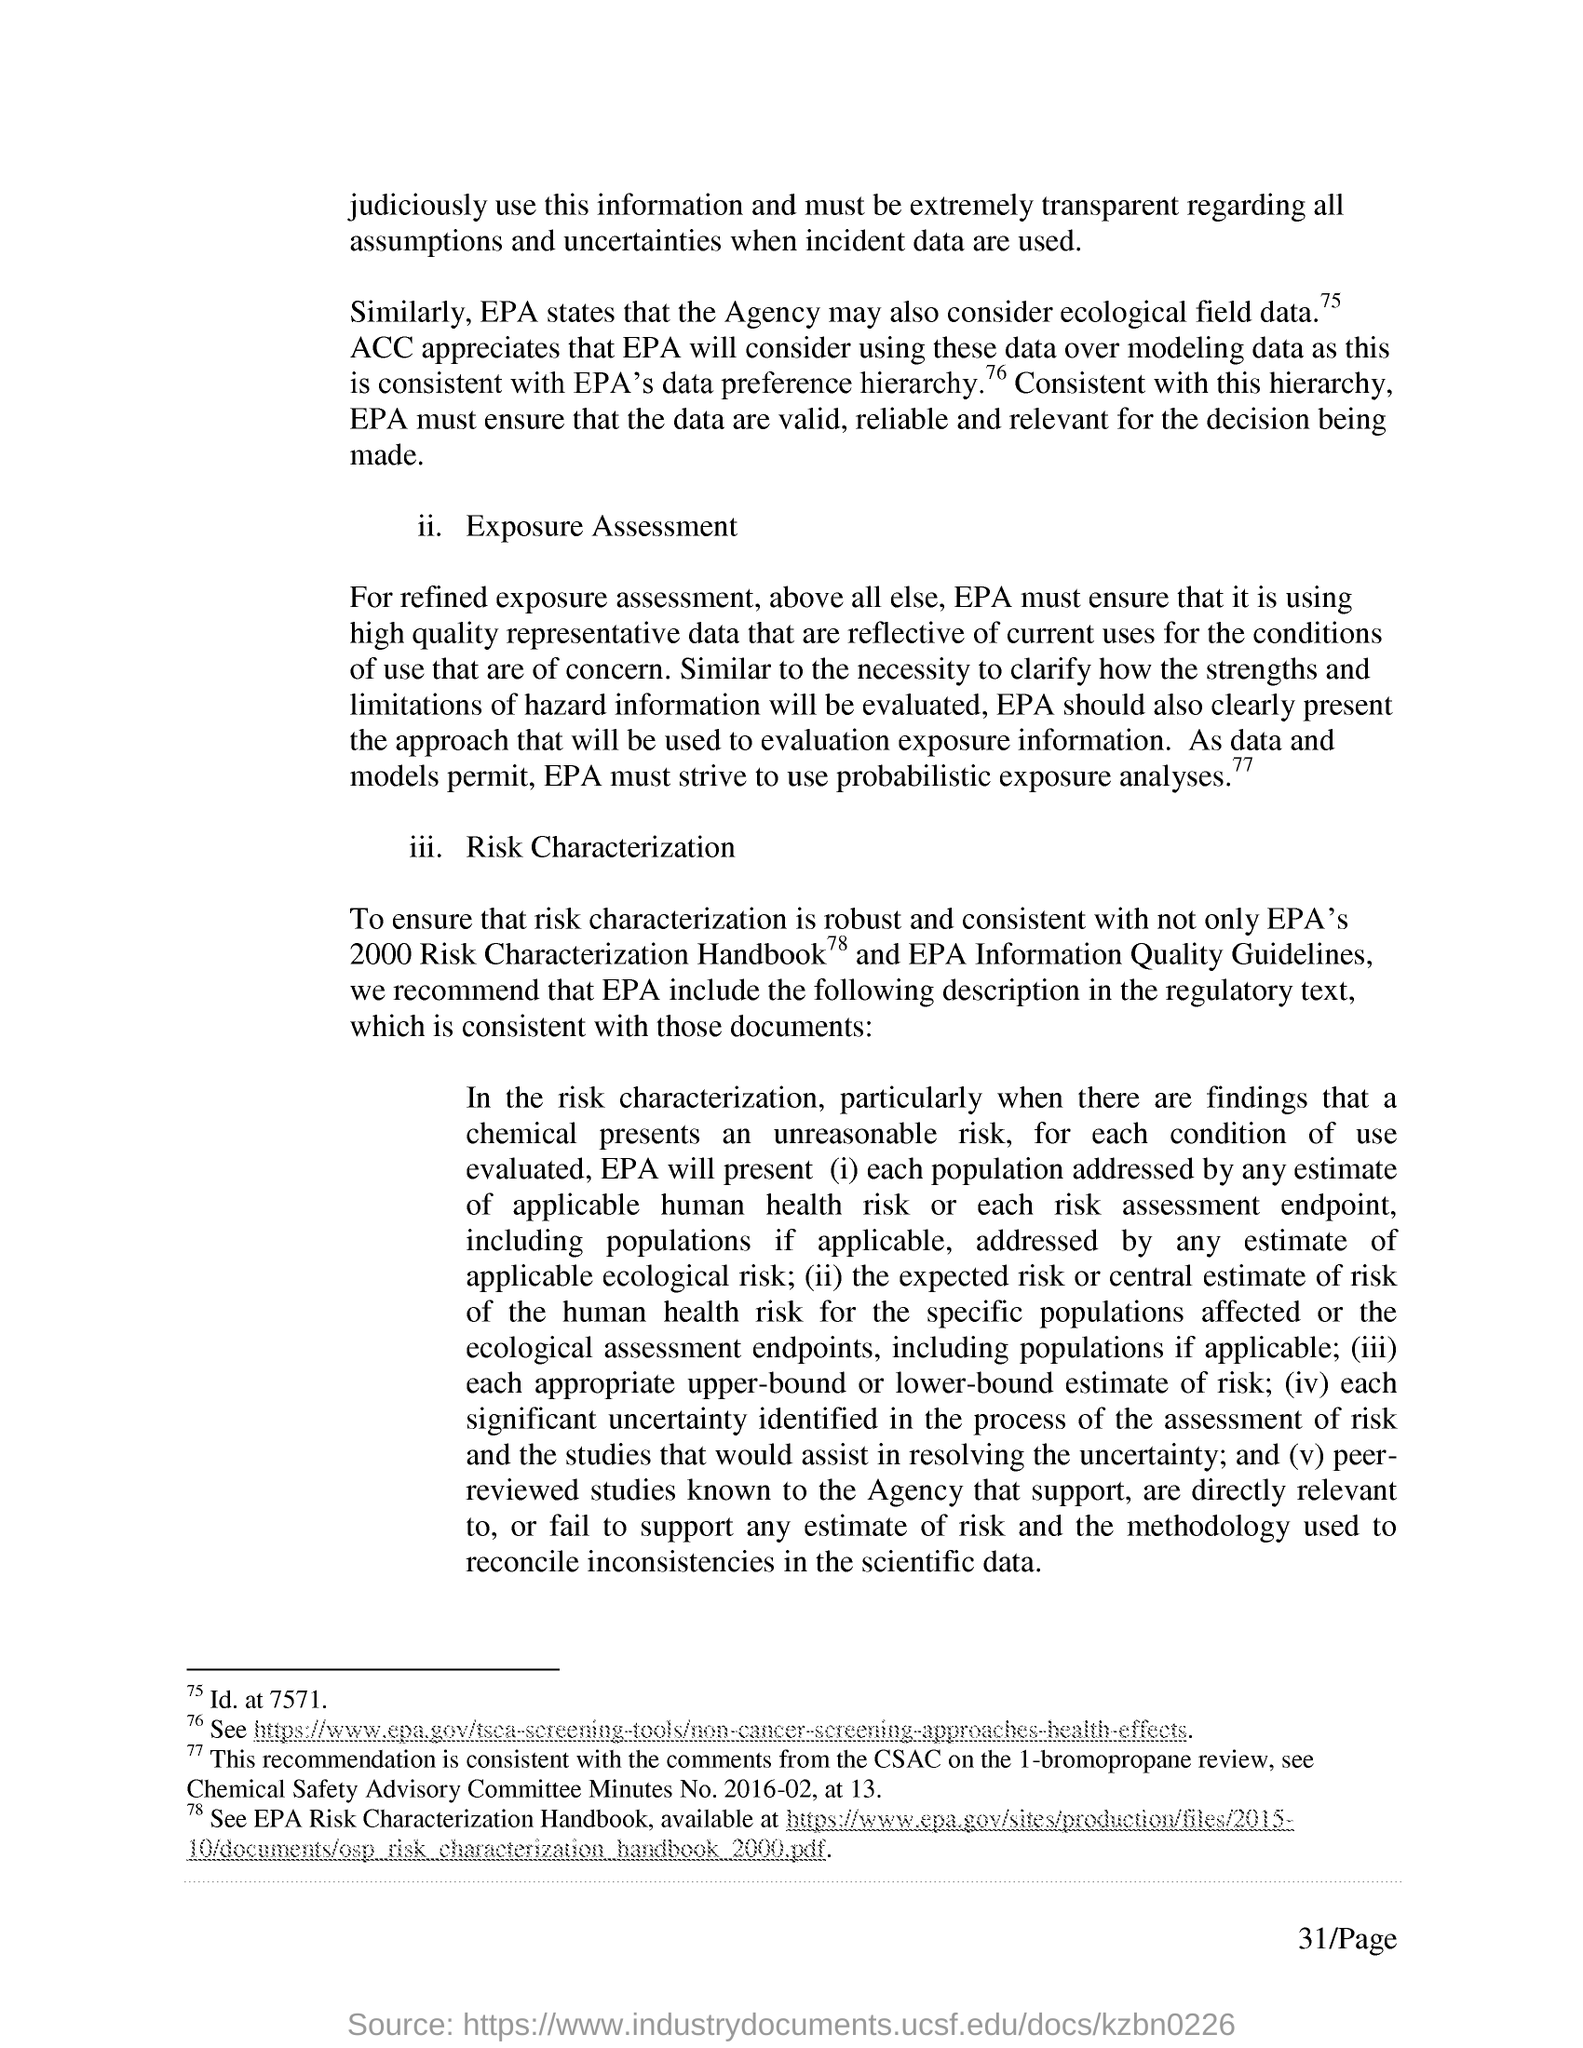What is the page no mentioned in this document?
Offer a very short reply. 31/Page. What is the abbreviation for Chemical Safety Advisory Committee?
Your answer should be very brief. CSAC. 